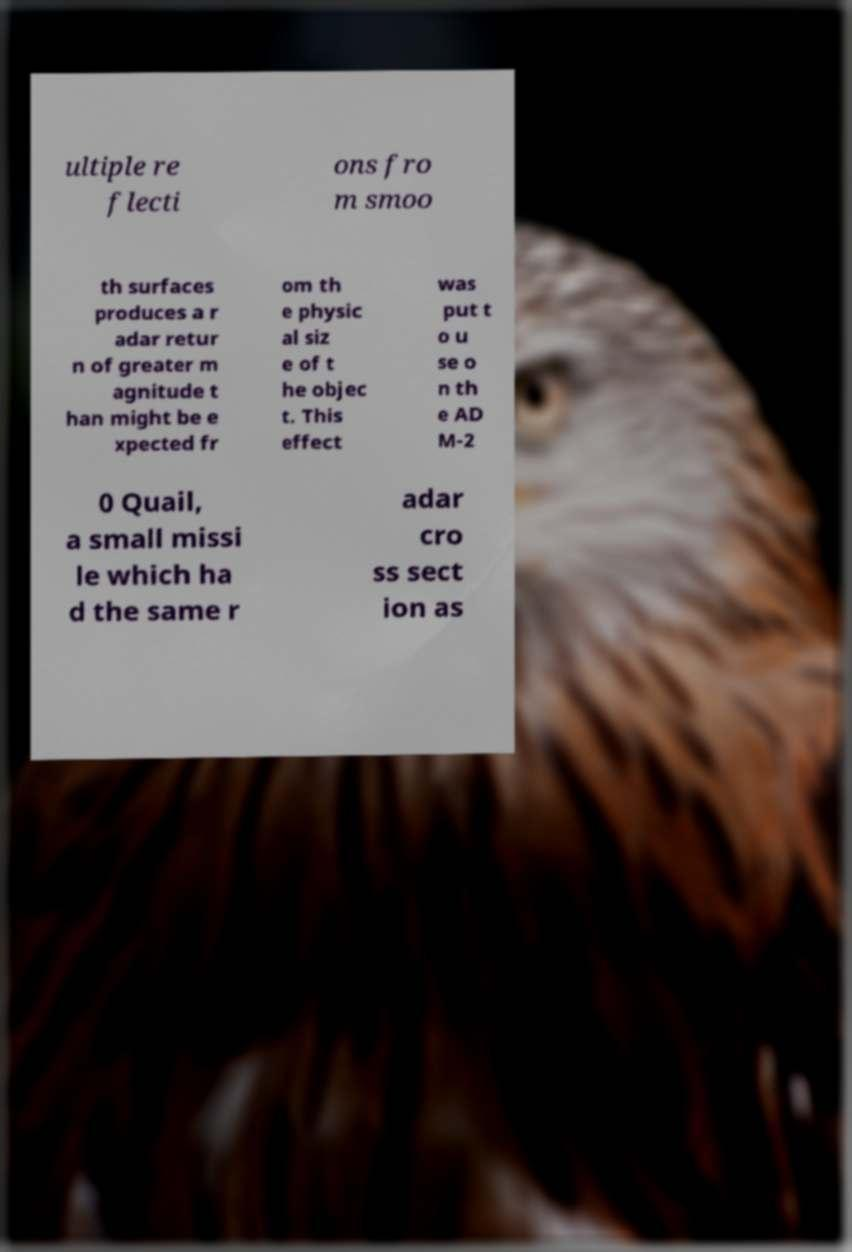Please identify and transcribe the text found in this image. ultiple re flecti ons fro m smoo th surfaces produces a r adar retur n of greater m agnitude t han might be e xpected fr om th e physic al siz e of t he objec t. This effect was put t o u se o n th e AD M-2 0 Quail, a small missi le which ha d the same r adar cro ss sect ion as 